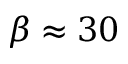<formula> <loc_0><loc_0><loc_500><loc_500>\beta \approx 3 0</formula> 